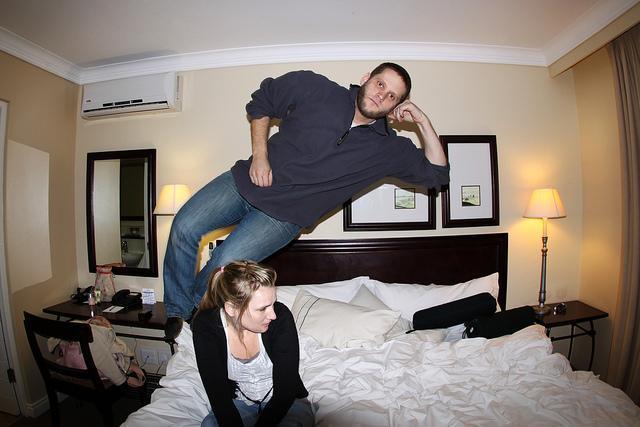Why does the man stand so strangely here?
Answer the question by selecting the correct answer among the 4 following choices.
Options: Disoriented, posing, he's ill, having seizure. Posing. 